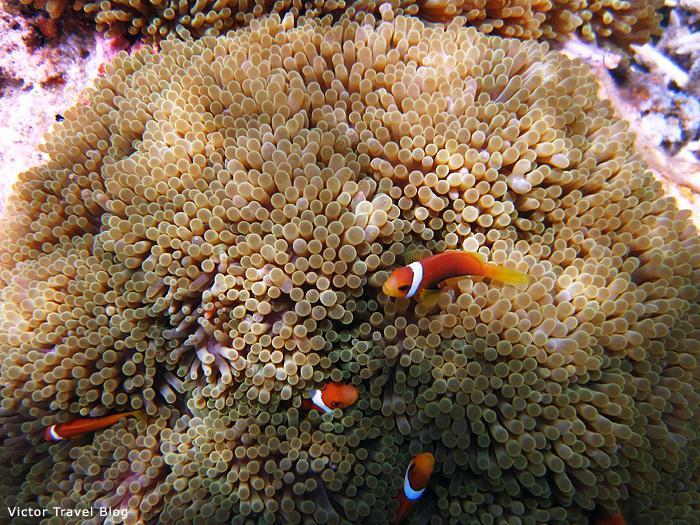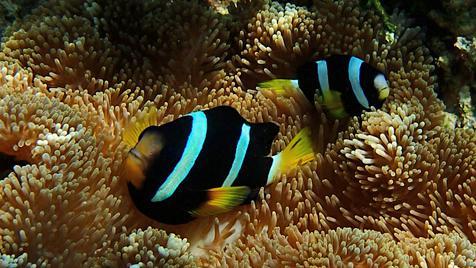The first image is the image on the left, the second image is the image on the right. Evaluate the accuracy of this statement regarding the images: "There are no more than two fish in the image on the left.". Is it true? Answer yes or no. No. The first image is the image on the left, the second image is the image on the right. For the images displayed, is the sentence "One image shows tendrils emerging from a vivid violet 'stalk', and the other image includes orange fish with three white stripes swimming near tendrils that are not neutral colored." factually correct? Answer yes or no. No. 